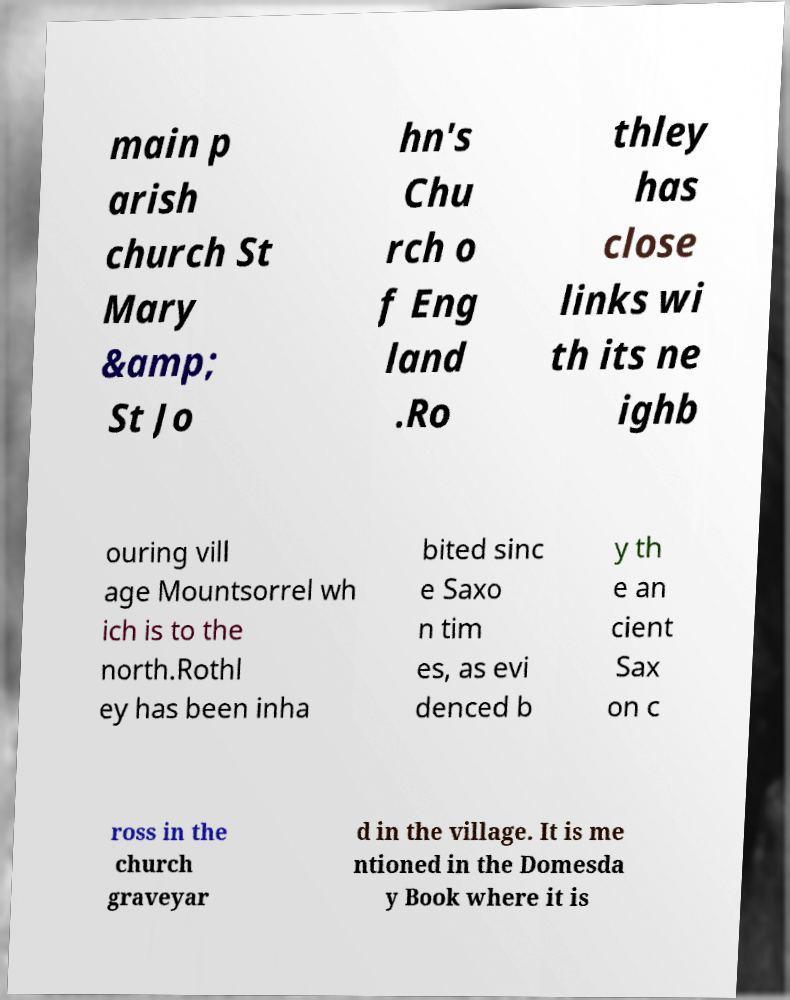Could you extract and type out the text from this image? main p arish church St Mary &amp; St Jo hn's Chu rch o f Eng land .Ro thley has close links wi th its ne ighb ouring vill age Mountsorrel wh ich is to the north.Rothl ey has been inha bited sinc e Saxo n tim es, as evi denced b y th e an cient Sax on c ross in the church graveyar d in the village. It is me ntioned in the Domesda y Book where it is 